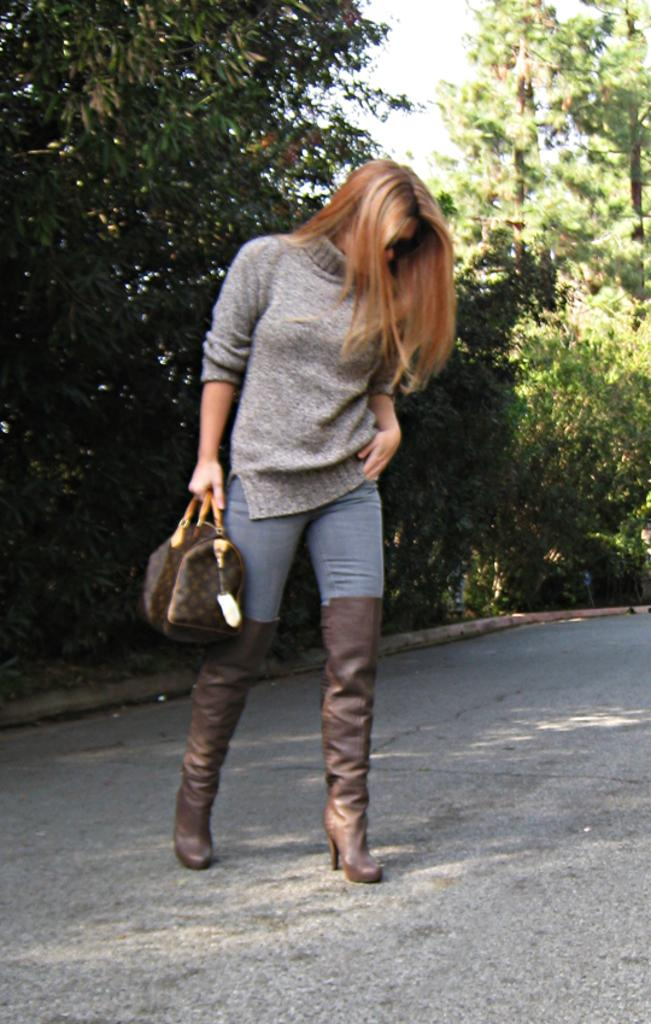Who is present in the image? There is a woman in the image. Where is the woman located? The woman is standing on a road. What can be seen near the road in the image? There are trees visible near the road. What is the woman carrying in the image? The woman is carrying a bag. What type of footwear is the woman wearing? The woman is wearing shoes. What type of competition is the woman participating in while standing on the road? There is no indication of a competition in the image; the woman is simply standing on the road. 